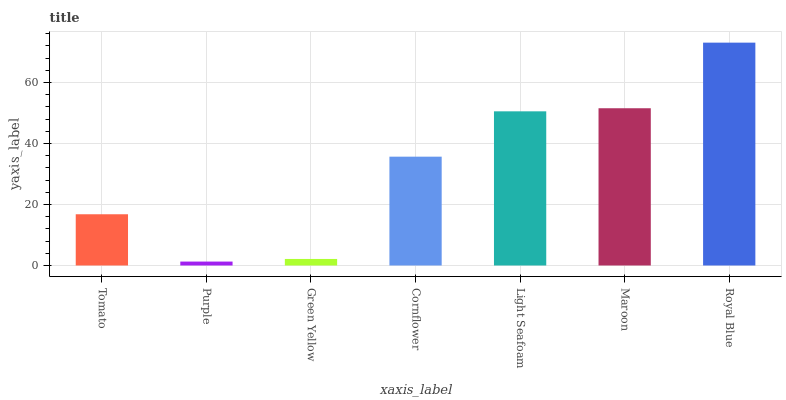Is Purple the minimum?
Answer yes or no. Yes. Is Royal Blue the maximum?
Answer yes or no. Yes. Is Green Yellow the minimum?
Answer yes or no. No. Is Green Yellow the maximum?
Answer yes or no. No. Is Green Yellow greater than Purple?
Answer yes or no. Yes. Is Purple less than Green Yellow?
Answer yes or no. Yes. Is Purple greater than Green Yellow?
Answer yes or no. No. Is Green Yellow less than Purple?
Answer yes or no. No. Is Cornflower the high median?
Answer yes or no. Yes. Is Cornflower the low median?
Answer yes or no. Yes. Is Green Yellow the high median?
Answer yes or no. No. Is Tomato the low median?
Answer yes or no. No. 